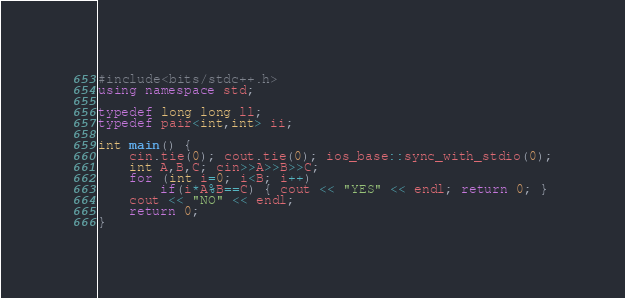Convert code to text. <code><loc_0><loc_0><loc_500><loc_500><_C++_>#include<bits/stdc++.h>
using namespace std;

typedef long long ll;
typedef pair<int,int> ii;

int main() {
	cin.tie(0); cout.tie(0); ios_base::sync_with_stdio(0);
	int A,B,C; cin>>A>>B>>C;
	for (int i=0; i<B; i++)
		if(i*A%B==C) { cout << "YES" << endl; return 0; }
	cout << "NO" << endl;
	return 0;
}
</code> 